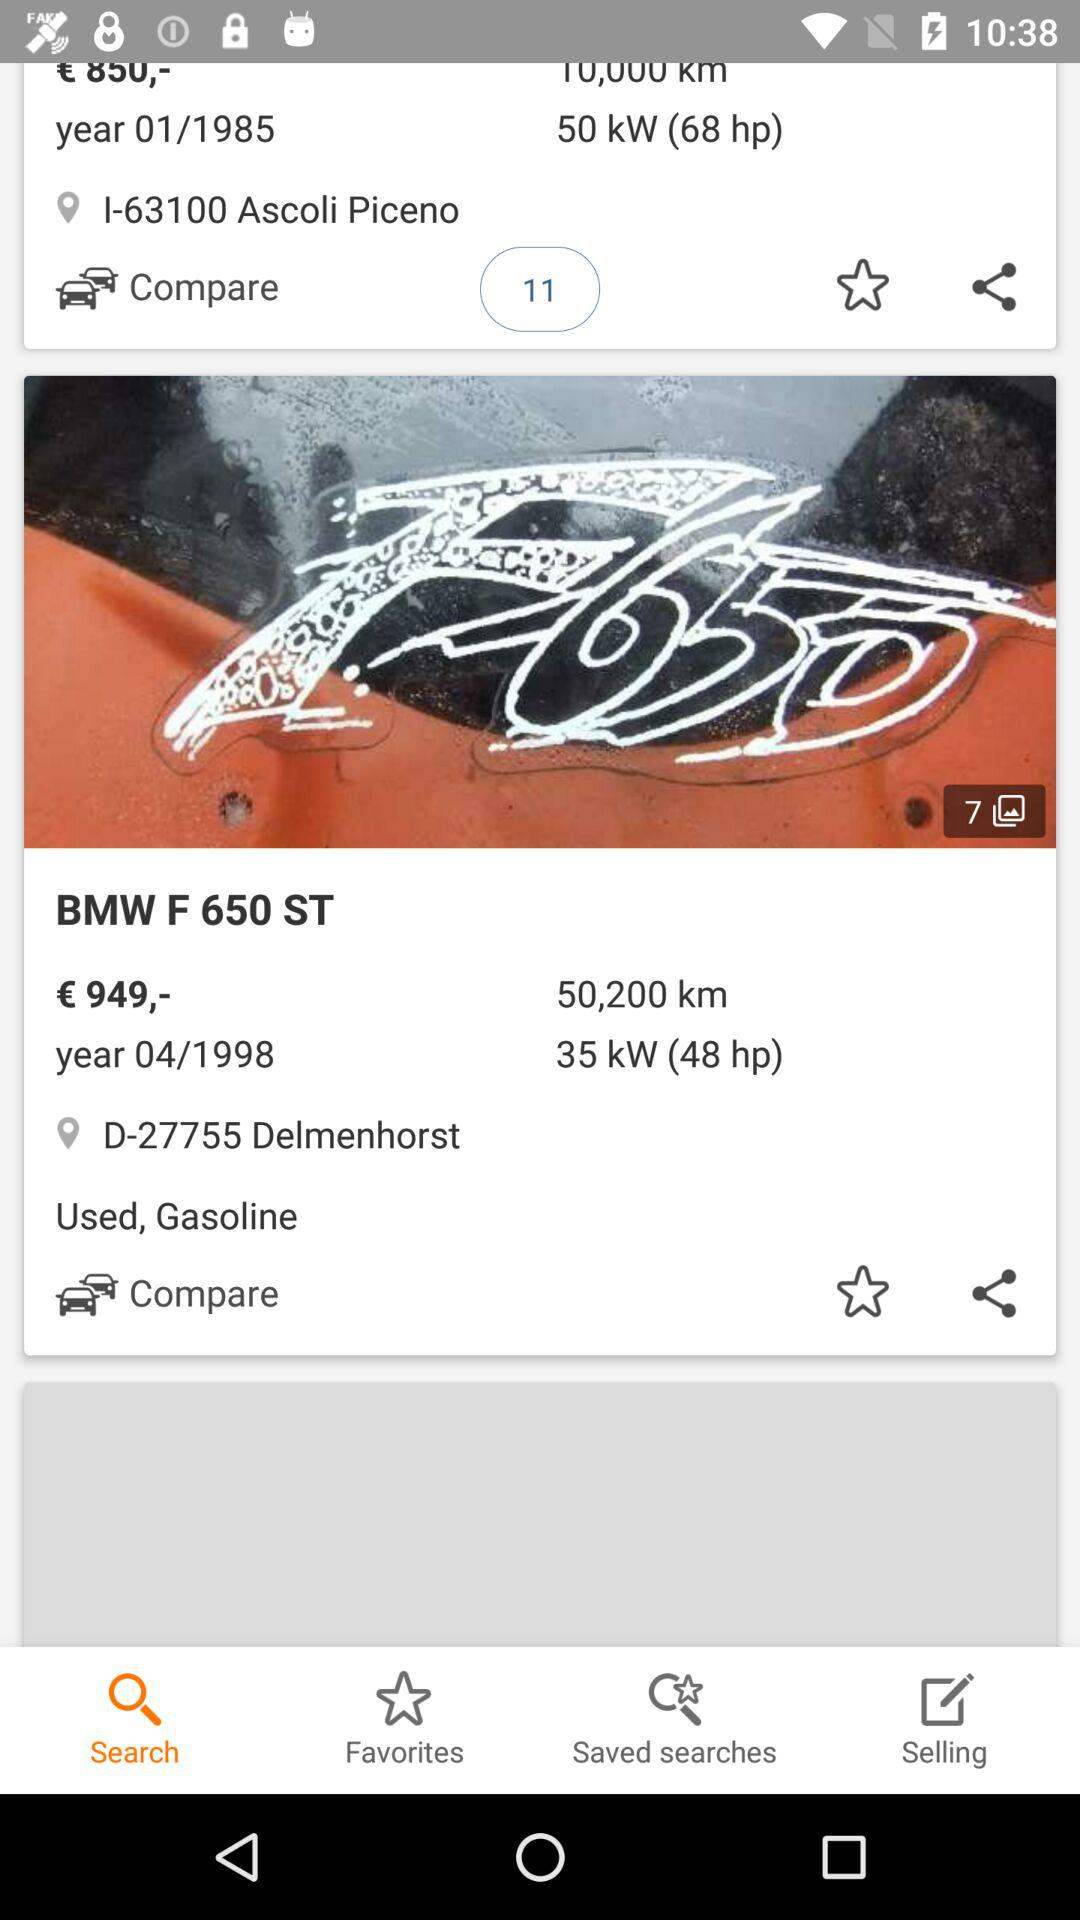What is the total number of photos? The total number of photos is 7. 